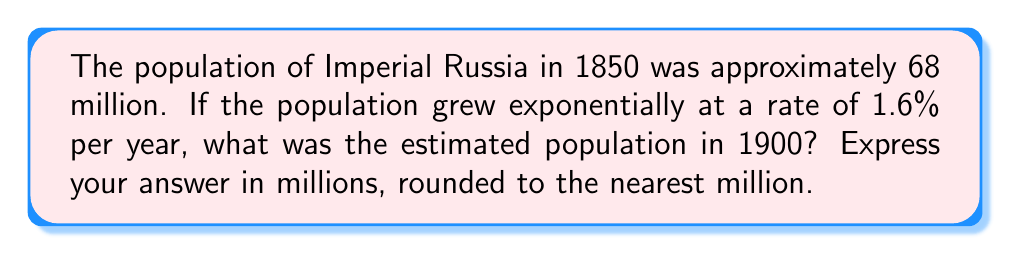Provide a solution to this math problem. As a Russian history professor, let's approach this problem using exponential growth functions:

1) The general form of exponential growth is:
   $P(t) = P_0 \cdot e^{rt}$
   
   Where:
   $P(t)$ is the population at time $t$
   $P_0$ is the initial population
   $r$ is the growth rate
   $t$ is the time elapsed

2) Given:
   $P_0 = 68$ million (population in 1850)
   $r = 0.016$ (1.6% annual growth rate)
   $t = 50$ years (from 1850 to 1900)

3) Substituting these values into our equation:
   $P(50) = 68 \cdot e^{0.016 \cdot 50}$

4) Simplify the exponent:
   $P(50) = 68 \cdot e^{0.8}$

5) Calculate:
   $P(50) = 68 \cdot e^{0.8}$
   $P(50) = 68 \cdot 2.2255$
   $P(50) = 151.334$ million

6) Rounding to the nearest million:
   $P(50) \approx 151$ million

Therefore, the estimated population of Imperial Russia in 1900 was approximately 151 million.
Answer: 151 million 